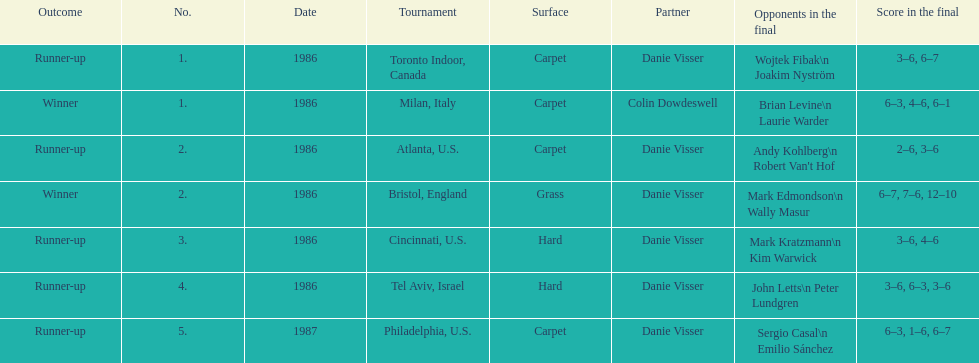What's the sum of grass and hard surfaces mentioned? 3. 